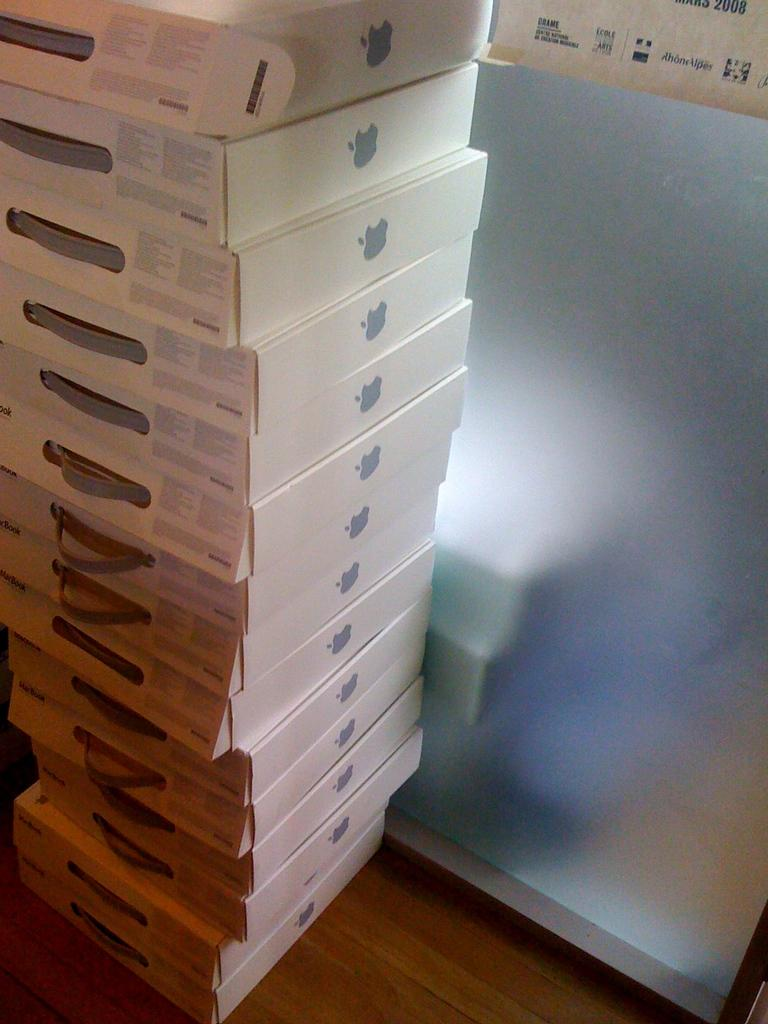What objects are present in the image? There are boxes in the image. Can you describe the boxes in more detail? Unfortunately, the provided facts do not offer any additional details about the boxes. Are the boxes stacked or arranged in any particular way? The provided facts do not specify the arrangement of the boxes. What type of fowl can be seen playing a game in the image? There is no fowl or game present in the image; it only features boxes. What kind of operation is being performed on the boxes in the image? The provided facts do not indicate any operation being performed on the boxes. 